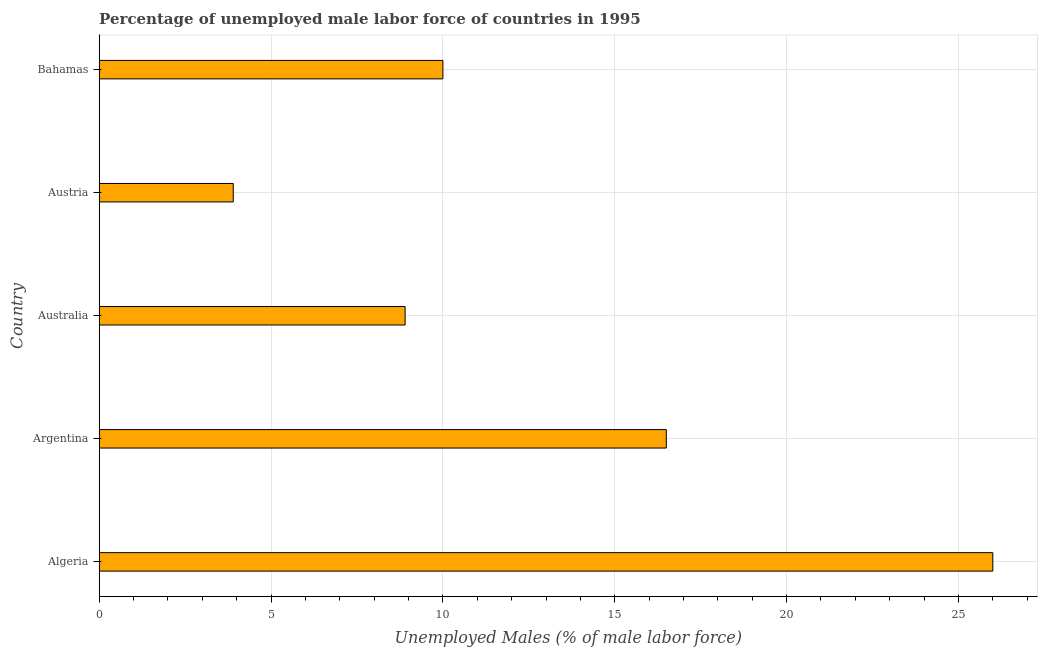Does the graph contain grids?
Your response must be concise. Yes. What is the title of the graph?
Offer a very short reply. Percentage of unemployed male labor force of countries in 1995. What is the label or title of the X-axis?
Provide a short and direct response. Unemployed Males (% of male labor force). Across all countries, what is the maximum total unemployed male labour force?
Provide a short and direct response. 26. Across all countries, what is the minimum total unemployed male labour force?
Give a very brief answer. 3.9. In which country was the total unemployed male labour force maximum?
Your response must be concise. Algeria. In which country was the total unemployed male labour force minimum?
Provide a succinct answer. Austria. What is the sum of the total unemployed male labour force?
Give a very brief answer. 65.3. What is the difference between the total unemployed male labour force in Algeria and Bahamas?
Give a very brief answer. 16. What is the average total unemployed male labour force per country?
Offer a very short reply. 13.06. What is the median total unemployed male labour force?
Your answer should be compact. 10. In how many countries, is the total unemployed male labour force greater than 17 %?
Give a very brief answer. 1. Is the total unemployed male labour force in Argentina less than that in Australia?
Your answer should be compact. No. What is the difference between the highest and the lowest total unemployed male labour force?
Provide a short and direct response. 22.1. How many bars are there?
Offer a very short reply. 5. How many countries are there in the graph?
Give a very brief answer. 5. What is the difference between two consecutive major ticks on the X-axis?
Give a very brief answer. 5. Are the values on the major ticks of X-axis written in scientific E-notation?
Ensure brevity in your answer.  No. What is the Unemployed Males (% of male labor force) of Algeria?
Give a very brief answer. 26. What is the Unemployed Males (% of male labor force) of Australia?
Keep it short and to the point. 8.9. What is the Unemployed Males (% of male labor force) in Austria?
Provide a succinct answer. 3.9. What is the Unemployed Males (% of male labor force) of Bahamas?
Provide a short and direct response. 10. What is the difference between the Unemployed Males (% of male labor force) in Algeria and Australia?
Your answer should be very brief. 17.1. What is the difference between the Unemployed Males (% of male labor force) in Algeria and Austria?
Give a very brief answer. 22.1. What is the difference between the Unemployed Males (% of male labor force) in Argentina and Austria?
Your response must be concise. 12.6. What is the difference between the Unemployed Males (% of male labor force) in Argentina and Bahamas?
Keep it short and to the point. 6.5. What is the difference between the Unemployed Males (% of male labor force) in Australia and Austria?
Your answer should be very brief. 5. What is the ratio of the Unemployed Males (% of male labor force) in Algeria to that in Argentina?
Give a very brief answer. 1.58. What is the ratio of the Unemployed Males (% of male labor force) in Algeria to that in Australia?
Keep it short and to the point. 2.92. What is the ratio of the Unemployed Males (% of male labor force) in Algeria to that in Austria?
Make the answer very short. 6.67. What is the ratio of the Unemployed Males (% of male labor force) in Algeria to that in Bahamas?
Keep it short and to the point. 2.6. What is the ratio of the Unemployed Males (% of male labor force) in Argentina to that in Australia?
Your answer should be compact. 1.85. What is the ratio of the Unemployed Males (% of male labor force) in Argentina to that in Austria?
Keep it short and to the point. 4.23. What is the ratio of the Unemployed Males (% of male labor force) in Argentina to that in Bahamas?
Provide a succinct answer. 1.65. What is the ratio of the Unemployed Males (% of male labor force) in Australia to that in Austria?
Make the answer very short. 2.28. What is the ratio of the Unemployed Males (% of male labor force) in Australia to that in Bahamas?
Offer a very short reply. 0.89. What is the ratio of the Unemployed Males (% of male labor force) in Austria to that in Bahamas?
Provide a succinct answer. 0.39. 